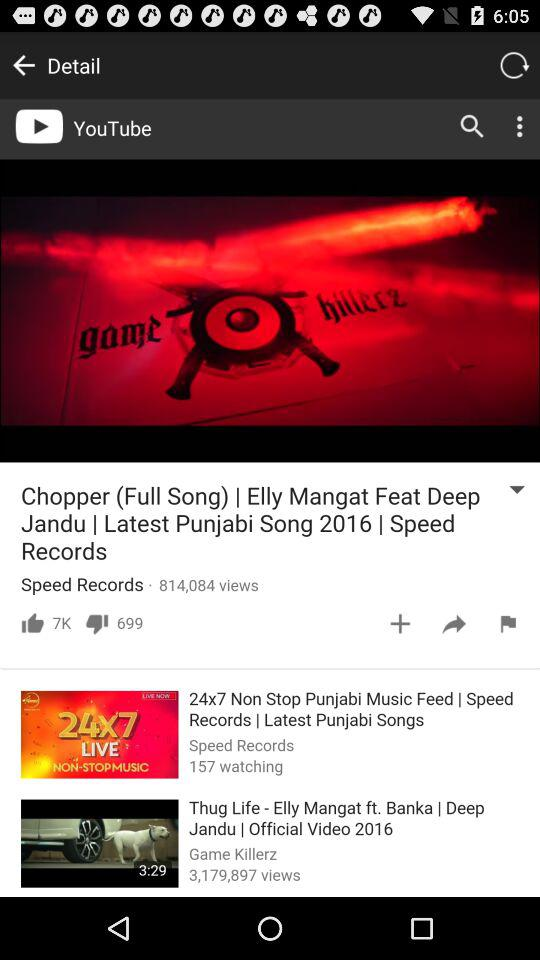How many views are on the "Chopper (Full Song)" video? There are 814,084 views on the "Chopper (Full Song)" video. 